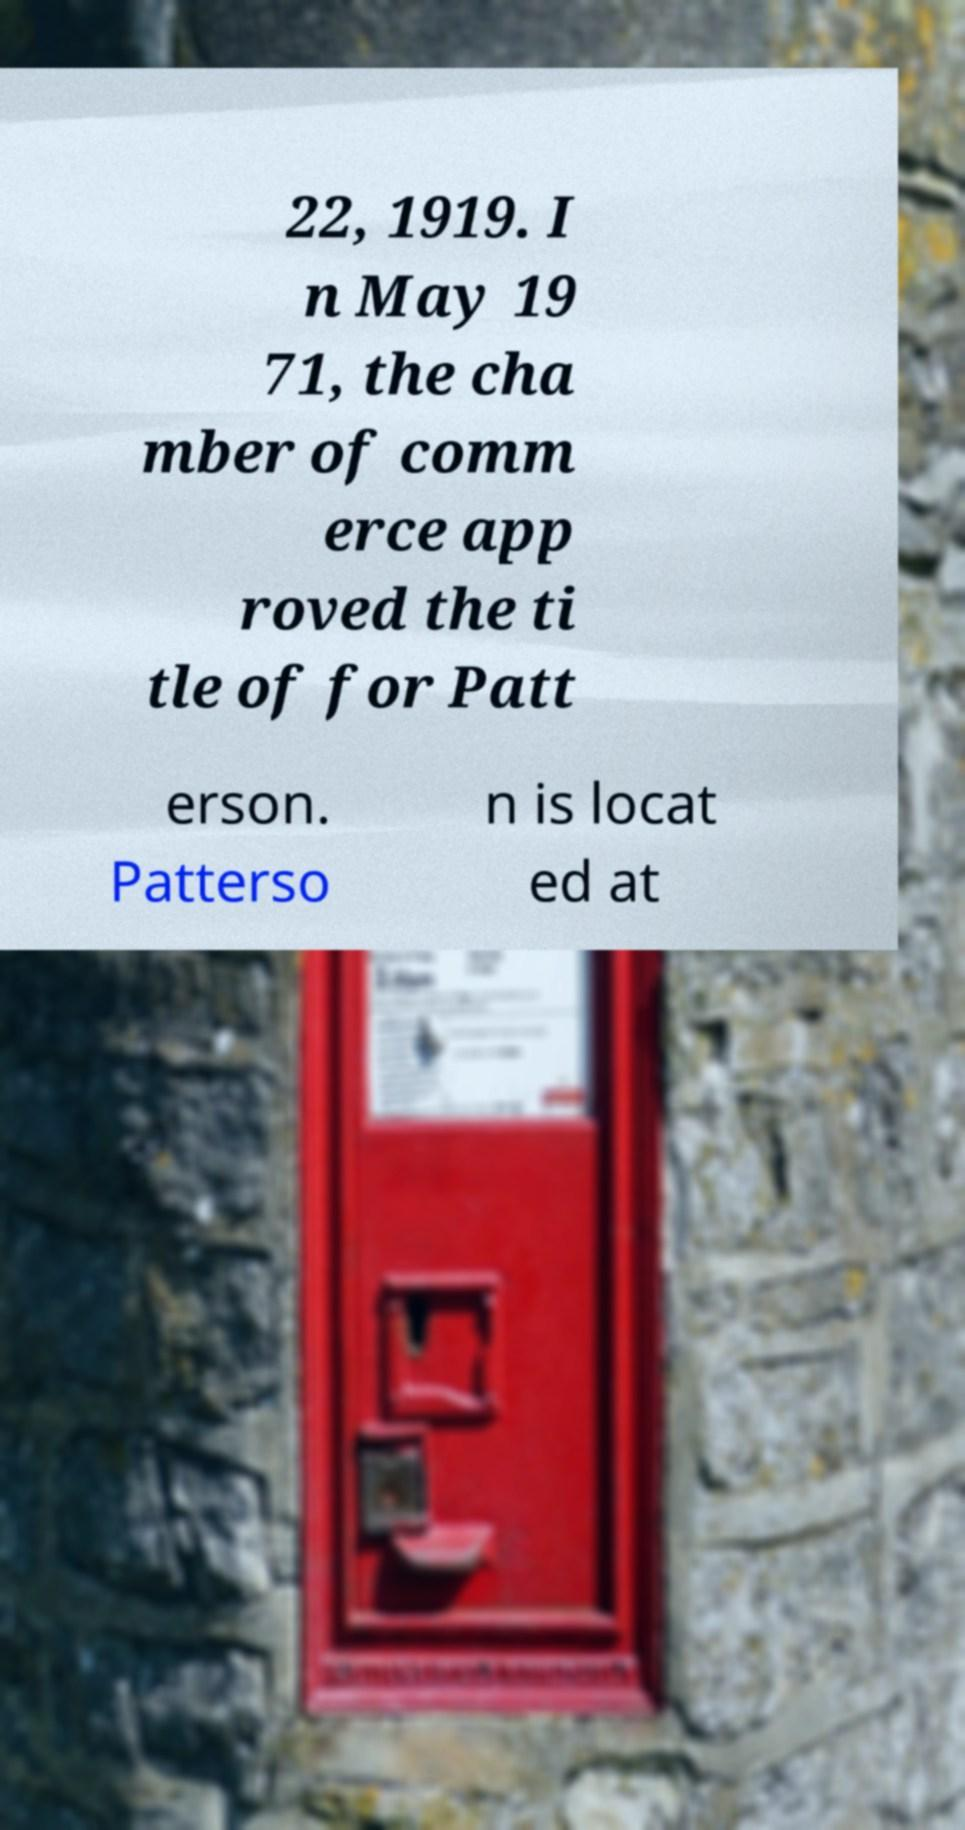For documentation purposes, I need the text within this image transcribed. Could you provide that? 22, 1919. I n May 19 71, the cha mber of comm erce app roved the ti tle of for Patt erson. Patterso n is locat ed at 